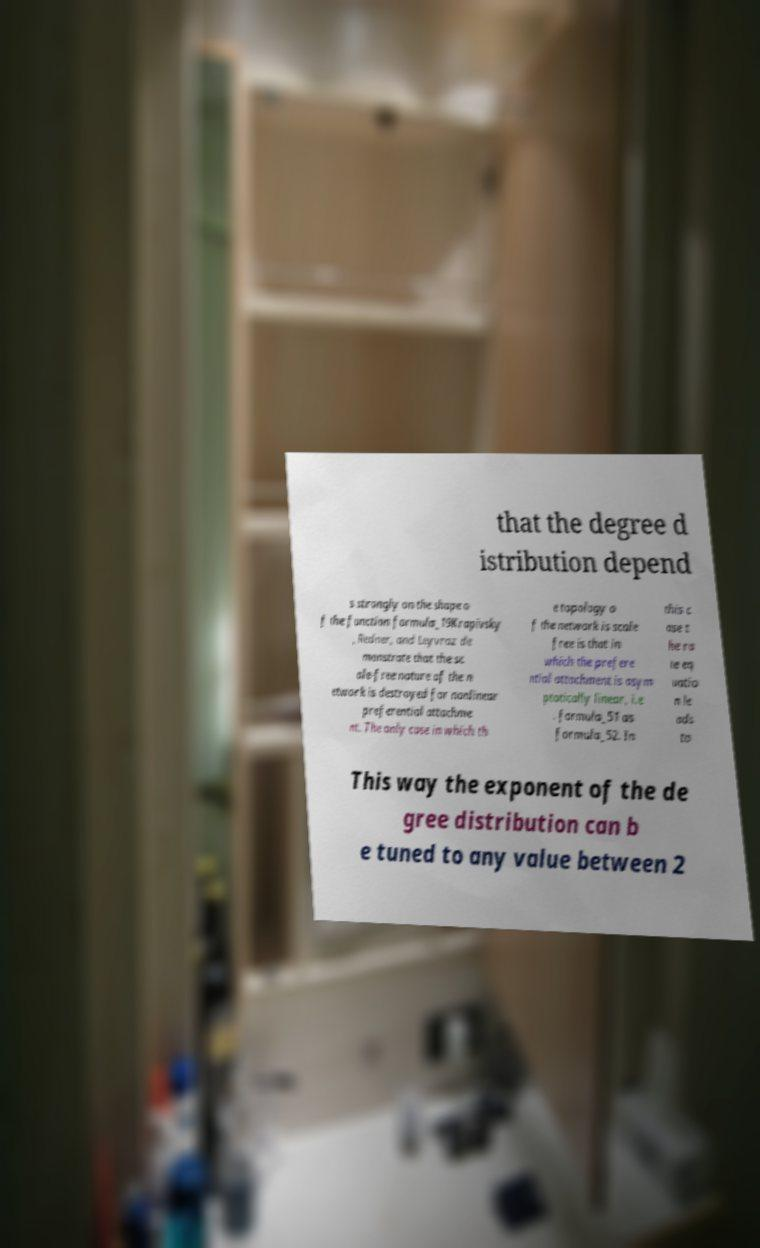Could you extract and type out the text from this image? that the degree d istribution depend s strongly on the shape o f the function formula_19Krapivsky , Redner, and Leyvraz de monstrate that the sc ale-free nature of the n etwork is destroyed for nonlinear preferential attachme nt. The only case in which th e topology o f the network is scale free is that in which the prefere ntial attachment is asym ptotically linear, i.e . formula_51 as formula_52. In this c ase t he ra te eq uatio n le ads to This way the exponent of the de gree distribution can b e tuned to any value between 2 